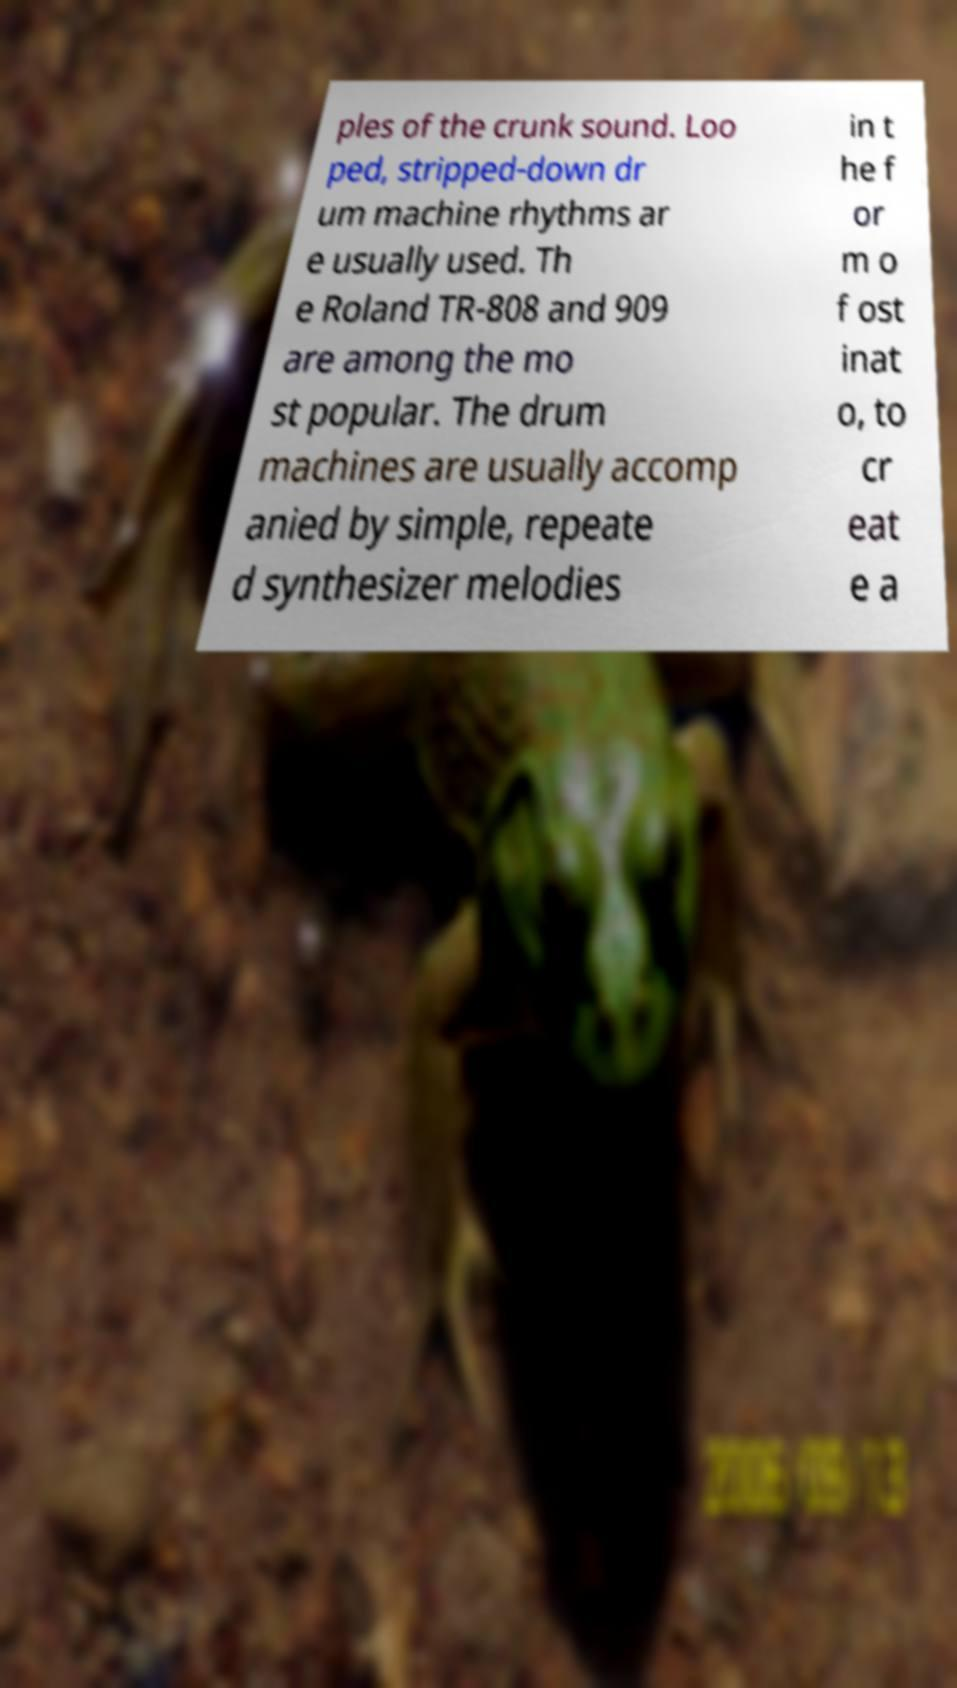What messages or text are displayed in this image? I need them in a readable, typed format. ples of the crunk sound. Loo ped, stripped-down dr um machine rhythms ar e usually used. Th e Roland TR-808 and 909 are among the mo st popular. The drum machines are usually accomp anied by simple, repeate d synthesizer melodies in t he f or m o f ost inat o, to cr eat e a 